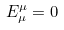<formula> <loc_0><loc_0><loc_500><loc_500>E _ { \mu } ^ { \mu } = 0</formula> 